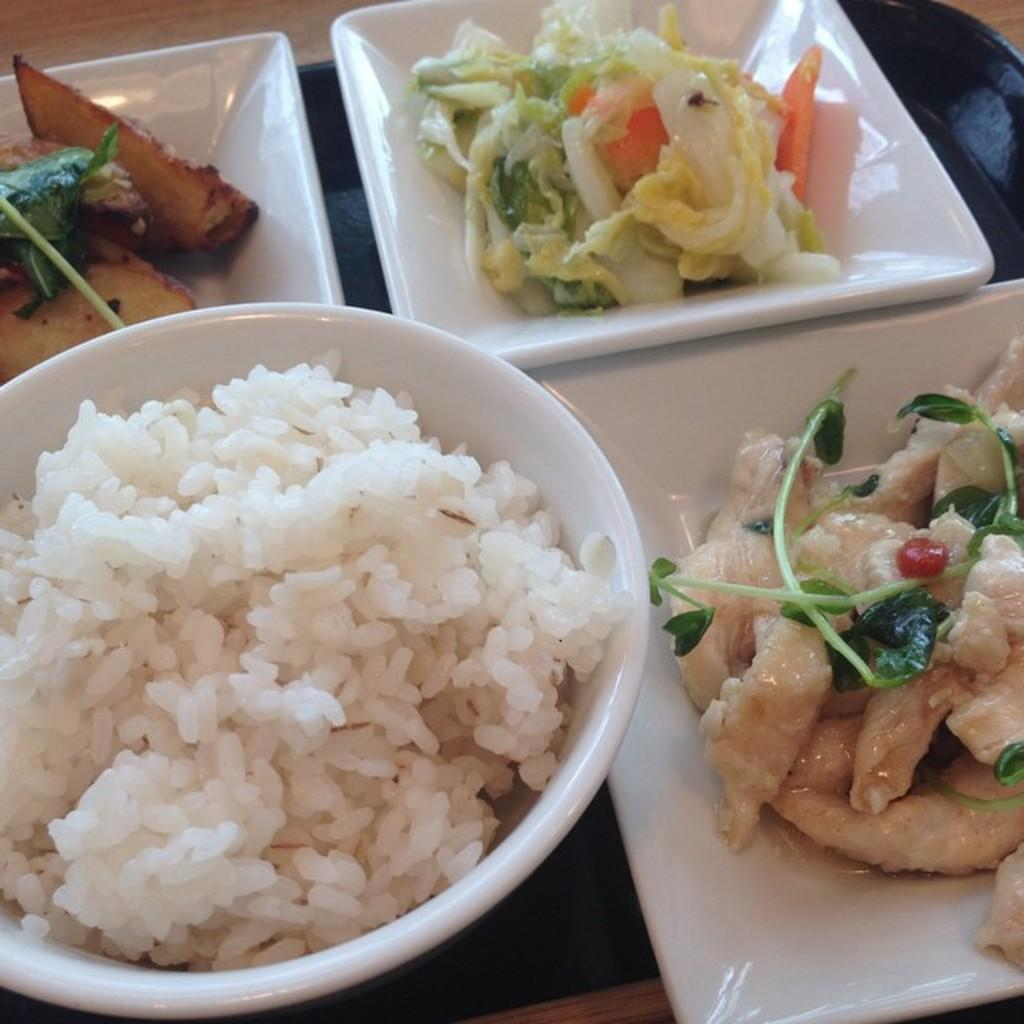What is the main object on the tray in the image? The tray contains a bowl of rice. What other food items are on the tray? The tray also contains plates of salad and plates of meat. On what type of table is the tray placed? The tray is placed on a wooden table. How many goldfish are swimming in the bowl of rice in the image? There are no goldfish present in the image; the bowl contains rice, not fish. What type of brass decoration can be seen on the plates of meat? There is no brass decoration on the plates of meat, as the provided facts do not mention any brass elements in the image. 